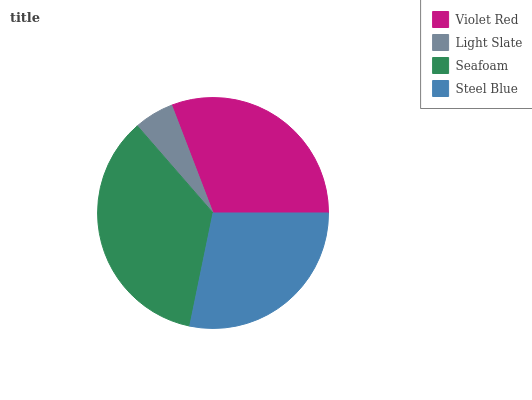Is Light Slate the minimum?
Answer yes or no. Yes. Is Seafoam the maximum?
Answer yes or no. Yes. Is Seafoam the minimum?
Answer yes or no. No. Is Light Slate the maximum?
Answer yes or no. No. Is Seafoam greater than Light Slate?
Answer yes or no. Yes. Is Light Slate less than Seafoam?
Answer yes or no. Yes. Is Light Slate greater than Seafoam?
Answer yes or no. No. Is Seafoam less than Light Slate?
Answer yes or no. No. Is Violet Red the high median?
Answer yes or no. Yes. Is Steel Blue the low median?
Answer yes or no. Yes. Is Light Slate the high median?
Answer yes or no. No. Is Seafoam the low median?
Answer yes or no. No. 